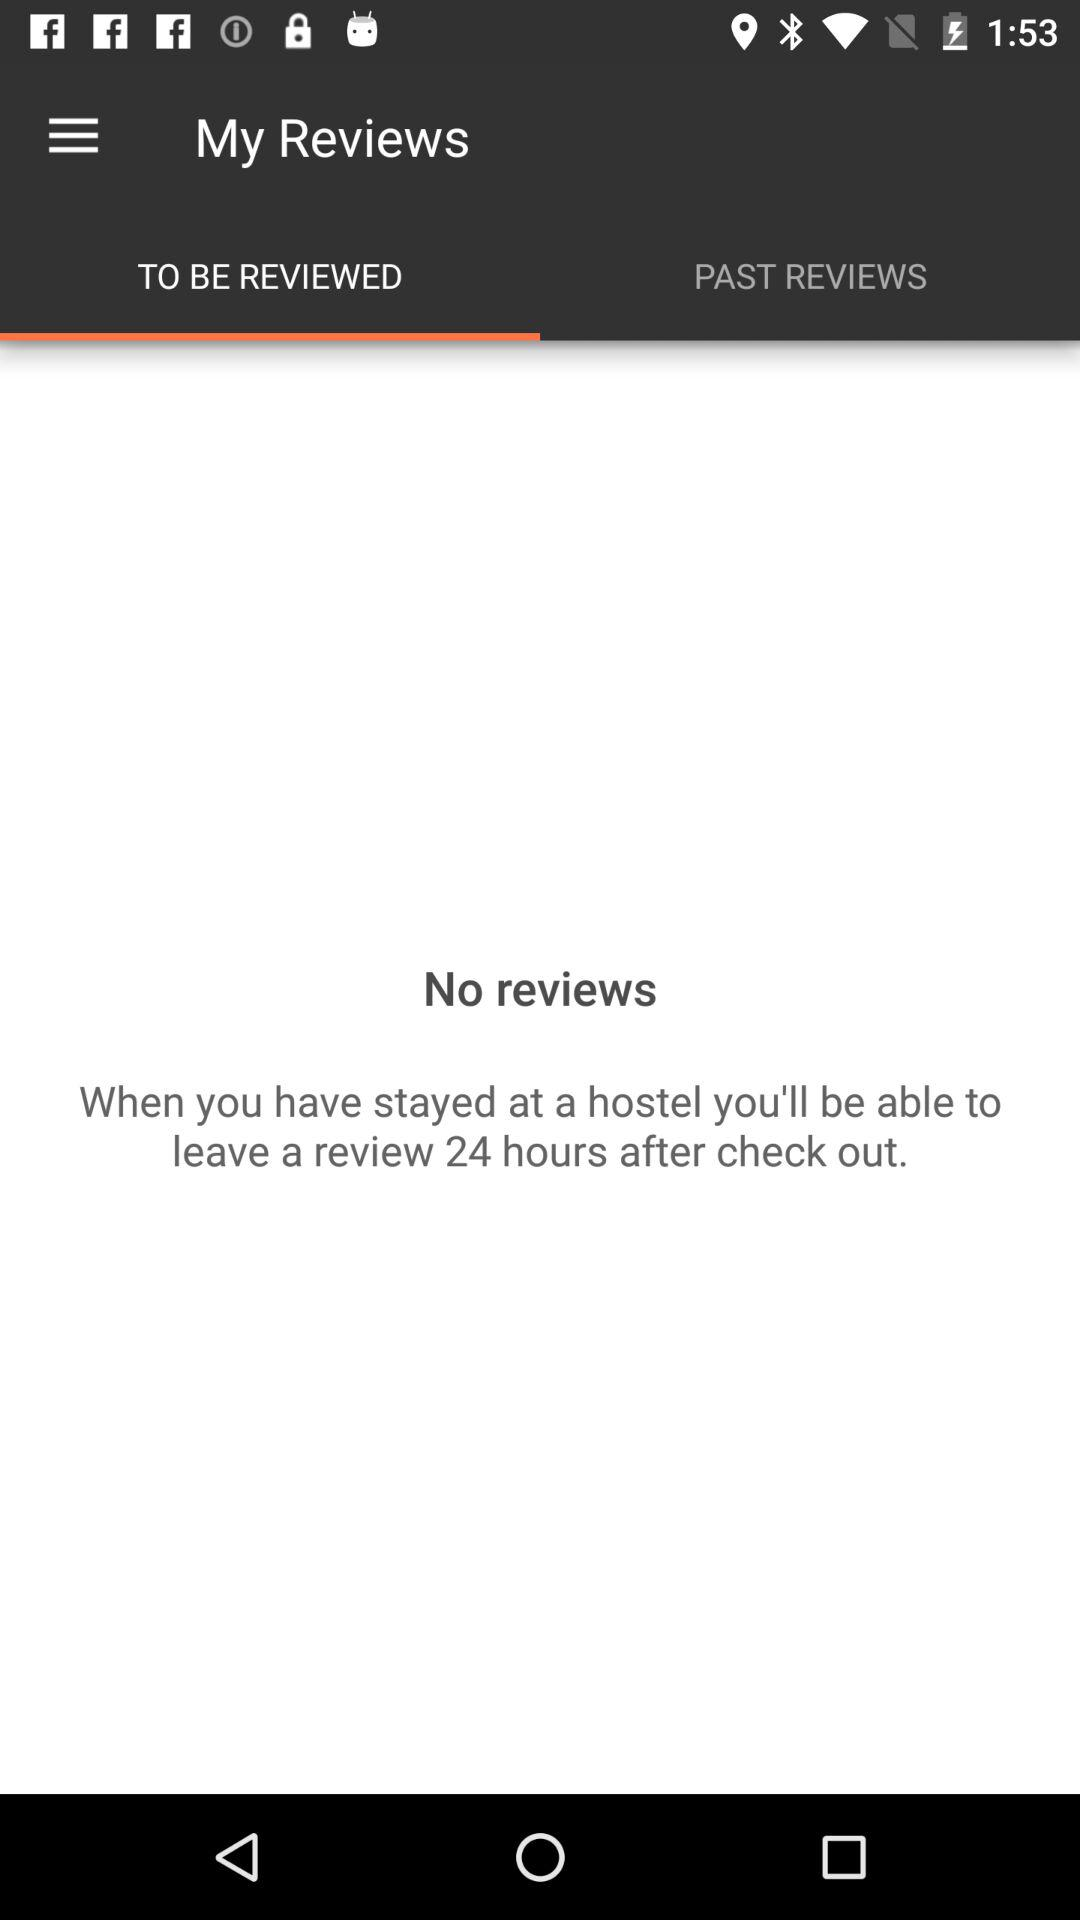How many reviews are there?
Answer the question using a single word or phrase. 0 